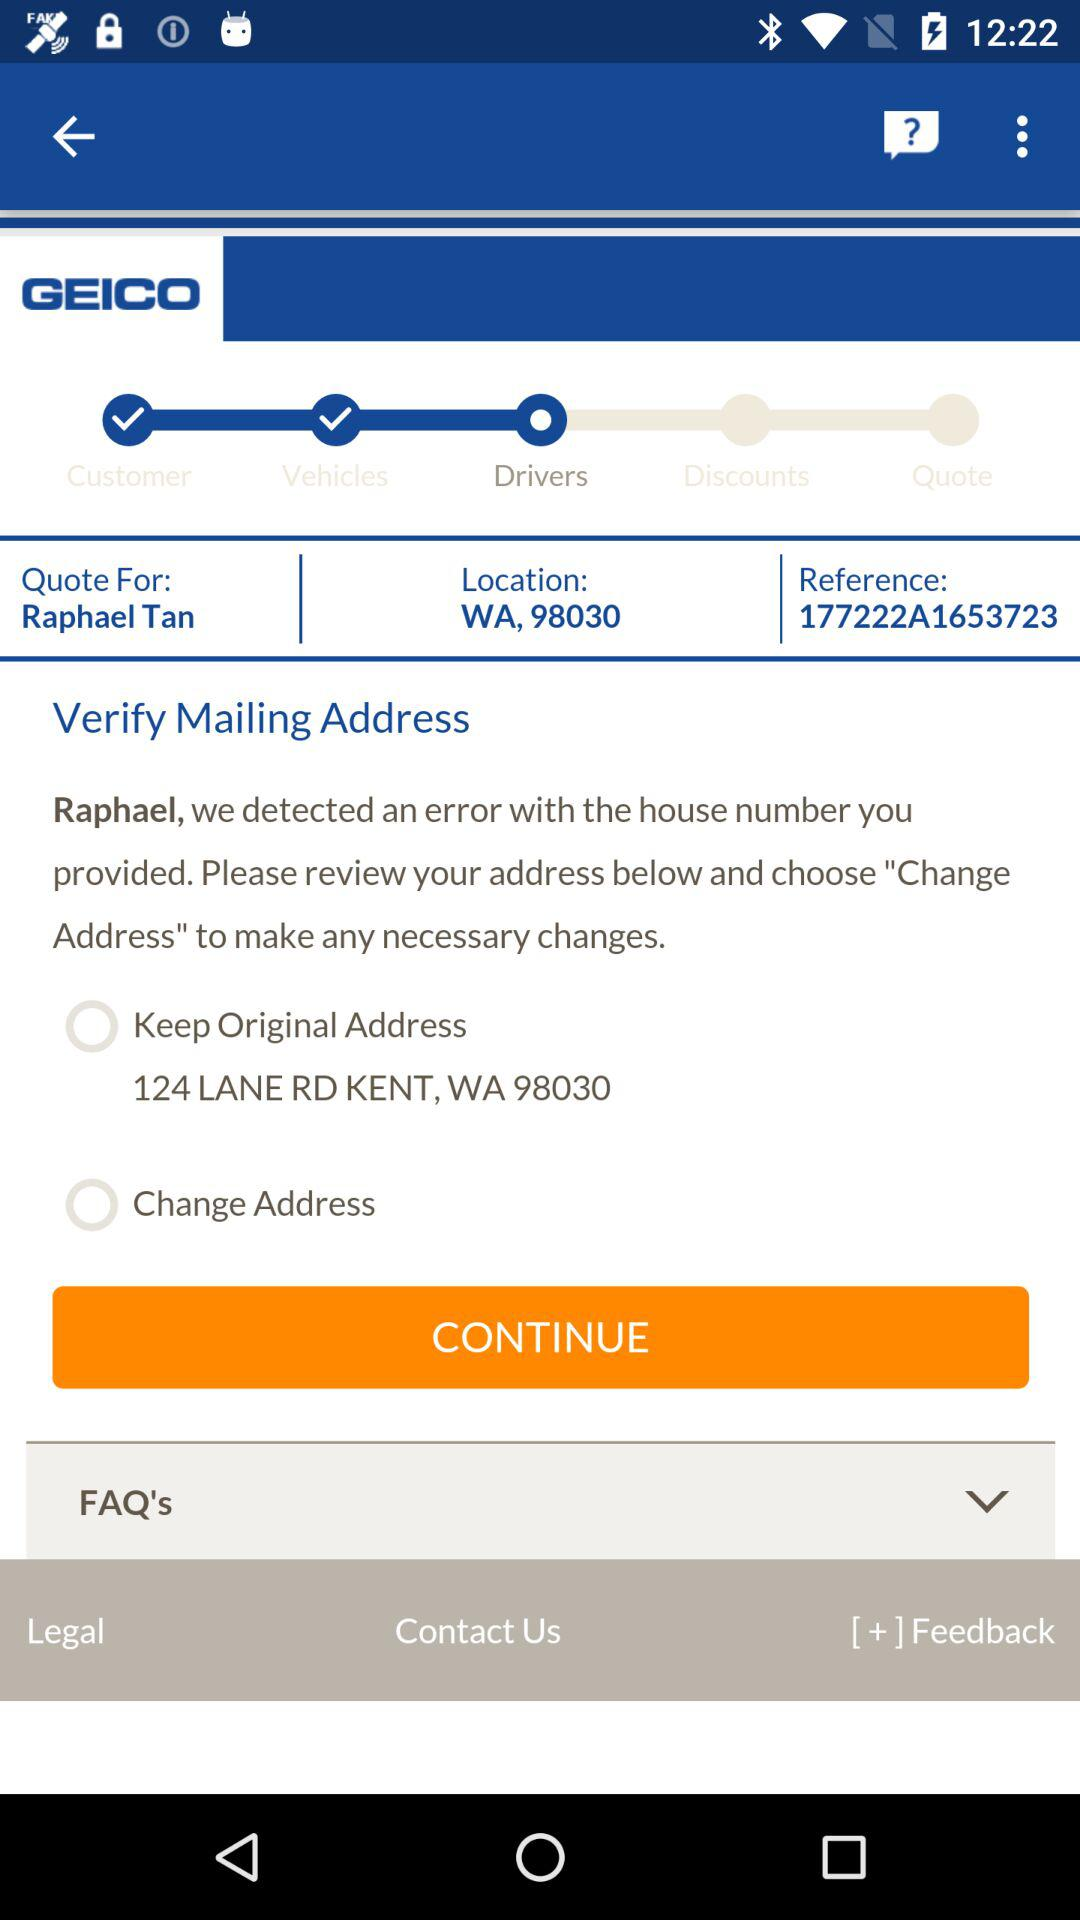What kind of vehicle does the user have?
When the provided information is insufficient, respond with <no answer>. <no answer> 